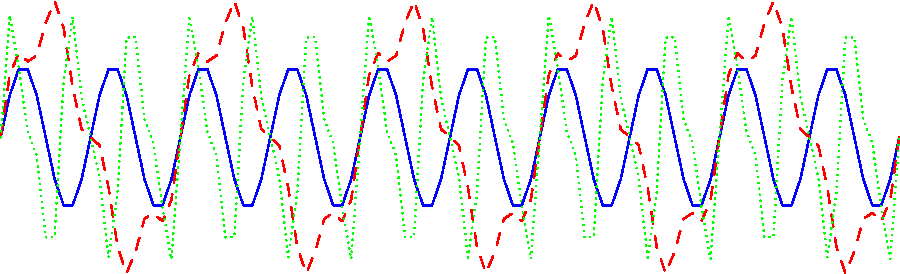As a hip-hop artist with a deep appreciation for classic rock, you're experimenting with guitar samples. Looking at the waveforms above, which technique would you use to create a punchy, rhythmic guitar sound that could complement a tight beat? Let's analyze each waveform to determine which technique would create a punchy, rhythmic guitar sound:

1. Blue (solid) line - "Clean":
   This waveform has a consistent, smooth sine wave pattern. It represents a clean guitar tone with no distortion or muting. While clear, it lacks the punch and aggression needed for a rhythmic backdrop.

2. Red (dashed) line - "Distorted":
   This waveform shows a more complex pattern with additional harmonics, indicated by the smaller, faster oscillations superimposed on the main wave. Distortion adds richness and sustain to the sound, but it might not provide the tight, punchy quality we're looking for.

3. Green (dotted) line - "Palm-muted":
   This waveform displays a higher frequency oscillation with a reduced amplitude compared to the others. Palm-muting is a technique where the guitarist lightly rests the palm of their picking hand on the strings near the bridge, resulting in a muted, percussive sound. This creates a tight, punchy tone that decays quickly.

For a hip-hop track requiring a punchy, rhythmic guitar sound to complement a tight beat, the palm-muted technique (green dotted line) would be the most suitable choice. It provides a percussive quality that can lock in with the drums and create a rhythmic foundation without overpowering other elements in the mix.
Answer: Palm-muted 